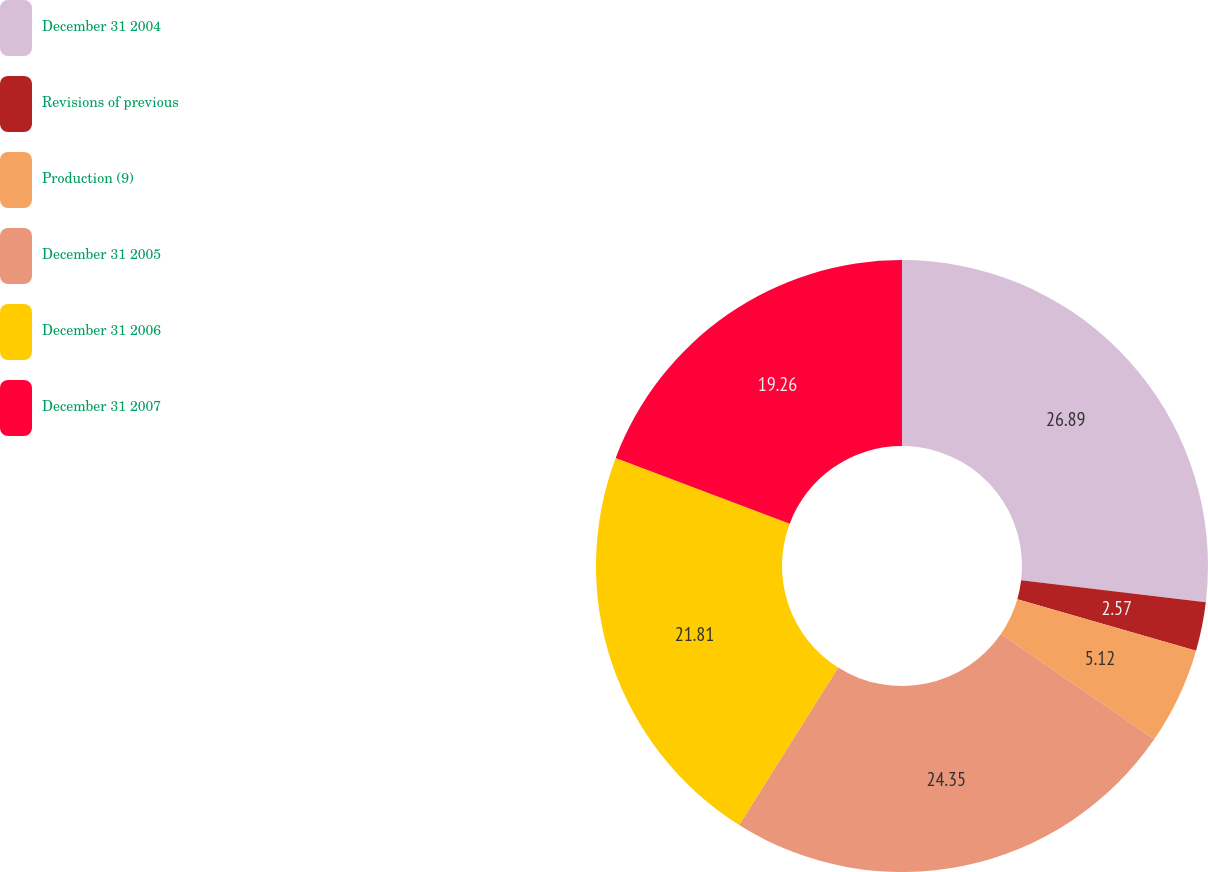<chart> <loc_0><loc_0><loc_500><loc_500><pie_chart><fcel>December 31 2004<fcel>Revisions of previous<fcel>Production (9)<fcel>December 31 2005<fcel>December 31 2006<fcel>December 31 2007<nl><fcel>26.89%<fcel>2.57%<fcel>5.12%<fcel>24.35%<fcel>21.81%<fcel>19.26%<nl></chart> 